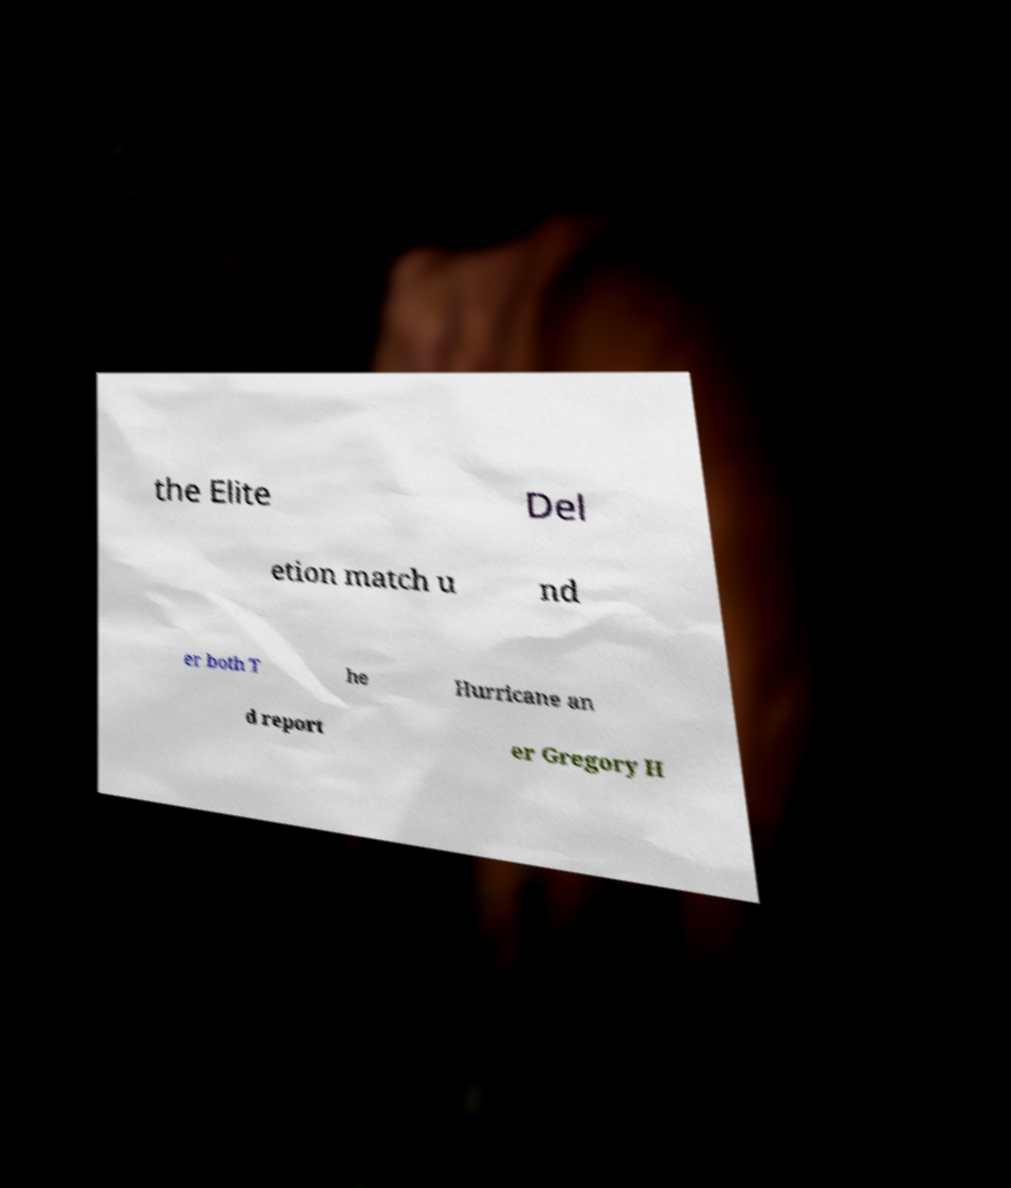There's text embedded in this image that I need extracted. Can you transcribe it verbatim? the Elite Del etion match u nd er both T he Hurricane an d report er Gregory H 